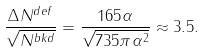<formula> <loc_0><loc_0><loc_500><loc_500>\frac { \Delta N ^ { d e f } } { \sqrt { N ^ { b k d } } } = \frac { 1 6 5 \alpha } { \sqrt { 7 3 5 \pi \alpha ^ { 2 } } } \approx 3 . 5 .</formula> 